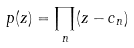<formula> <loc_0><loc_0><loc_500><loc_500>p ( z ) = \prod _ { n } ( z - c _ { n } )</formula> 